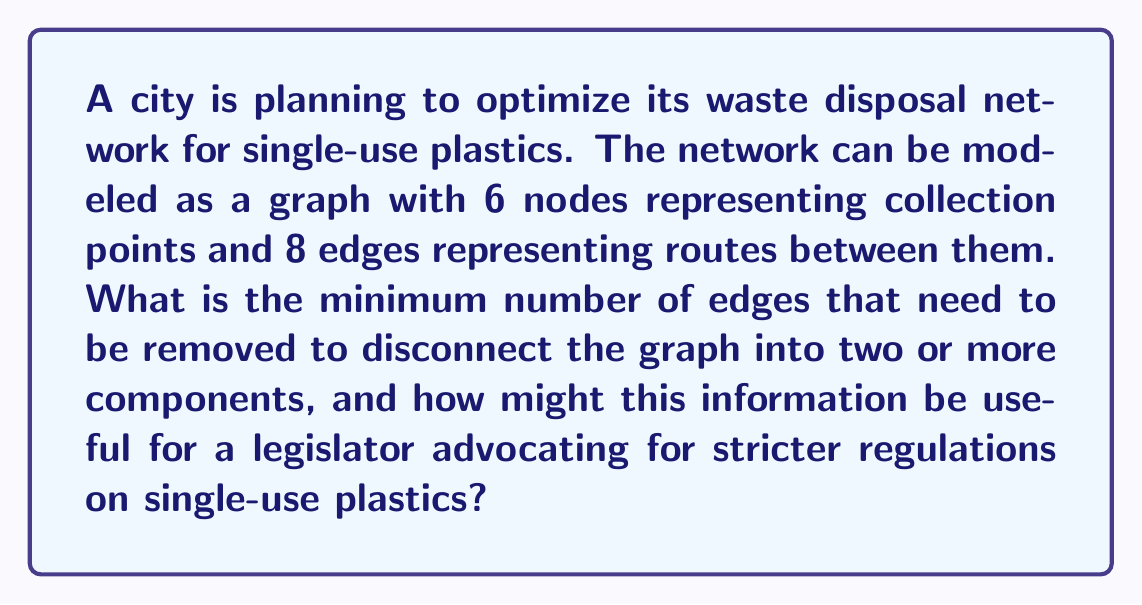Show me your answer to this math problem. To solve this problem, we need to find the edge connectivity of the given graph. The edge connectivity of a graph is the minimum number of edges that need to be removed to disconnect the graph.

Let's approach this step-by-step:

1) First, we need to understand that the maximum possible edge connectivity for a graph with 6 nodes is 5, as each node can be connected to at most 5 other nodes.

2) Given that we have 8 edges in total, we know that the graph is not complete (a complete graph with 6 nodes would have 15 edges).

3) To find the minimum number of edges to disconnect the graph, we need to find the smallest cut set. In graph theory, a cut set is a set of edges whose removal disconnects the graph.

4) Without a specific graph structure given, we can assume the worst-case scenario for disconnection, which would be a graph with the highest possible connectivity given the constraints.

5) The most connected graph possible with 6 nodes and 8 edges would be a graph where 5 nodes have degree 3, and 1 node has degree 2.

6) In this case, the minimum cut would be removing all edges connected to the node with the lowest degree, which is 2.

Therefore, the edge connectivity of this graph is 2.

For a legislator advocating for stricter regulations on single-use plastics, this information could be useful in several ways:

1) It highlights the vulnerability of the waste disposal network. If just two routes are disrupted, the entire network could be disconnected.

2) It emphasizes the need for redundancy in waste management systems, especially for single-use plastics which are produced and discarded in large volumes.

3) It could be used to argue for increased investment in waste disposal infrastructure to increase the network's resilience.

4) It might support arguments for localized recycling facilities to reduce dependency on a centralized network.

5) It could be used to demonstrate the potential environmental risks if parts of the network become isolated due to disruptions.
Answer: The minimum number of edges that need to be removed to disconnect the graph is 2. This information can be used by a legislator to advocate for more robust and redundant waste disposal networks for single-use plastics, emphasizing the need for increased infrastructure investment and localized recycling facilities to improve network resilience and reduce environmental risks. 